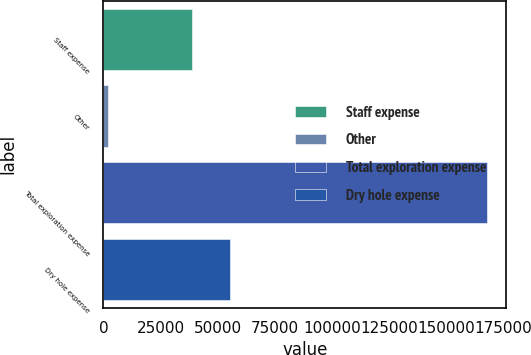<chart> <loc_0><loc_0><loc_500><loc_500><bar_chart><fcel>Staff expense<fcel>Other<fcel>Total exploration expense<fcel>Dry hole expense<nl><fcel>38861<fcel>2226<fcel>167924<fcel>55430.8<nl></chart> 